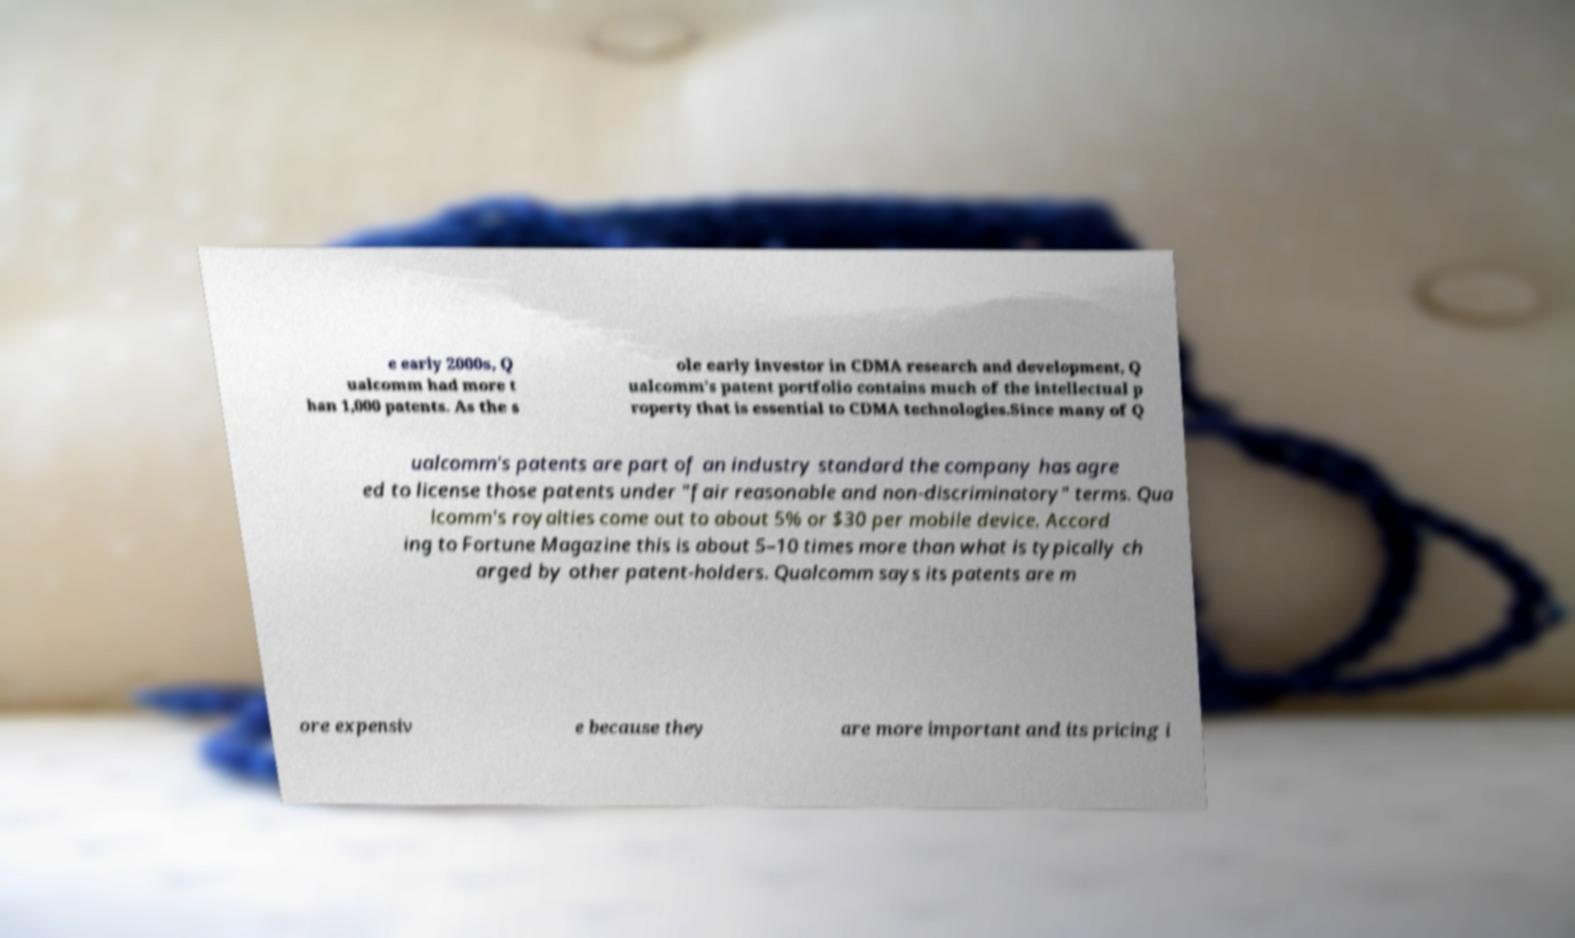Can you accurately transcribe the text from the provided image for me? e early 2000s, Q ualcomm had more t han 1,000 patents. As the s ole early investor in CDMA research and development, Q ualcomm's patent portfolio contains much of the intellectual p roperty that is essential to CDMA technologies.Since many of Q ualcomm's patents are part of an industry standard the company has agre ed to license those patents under "fair reasonable and non-discriminatory" terms. Qua lcomm's royalties come out to about 5% or $30 per mobile device. Accord ing to Fortune Magazine this is about 5–10 times more than what is typically ch arged by other patent-holders. Qualcomm says its patents are m ore expensiv e because they are more important and its pricing i 